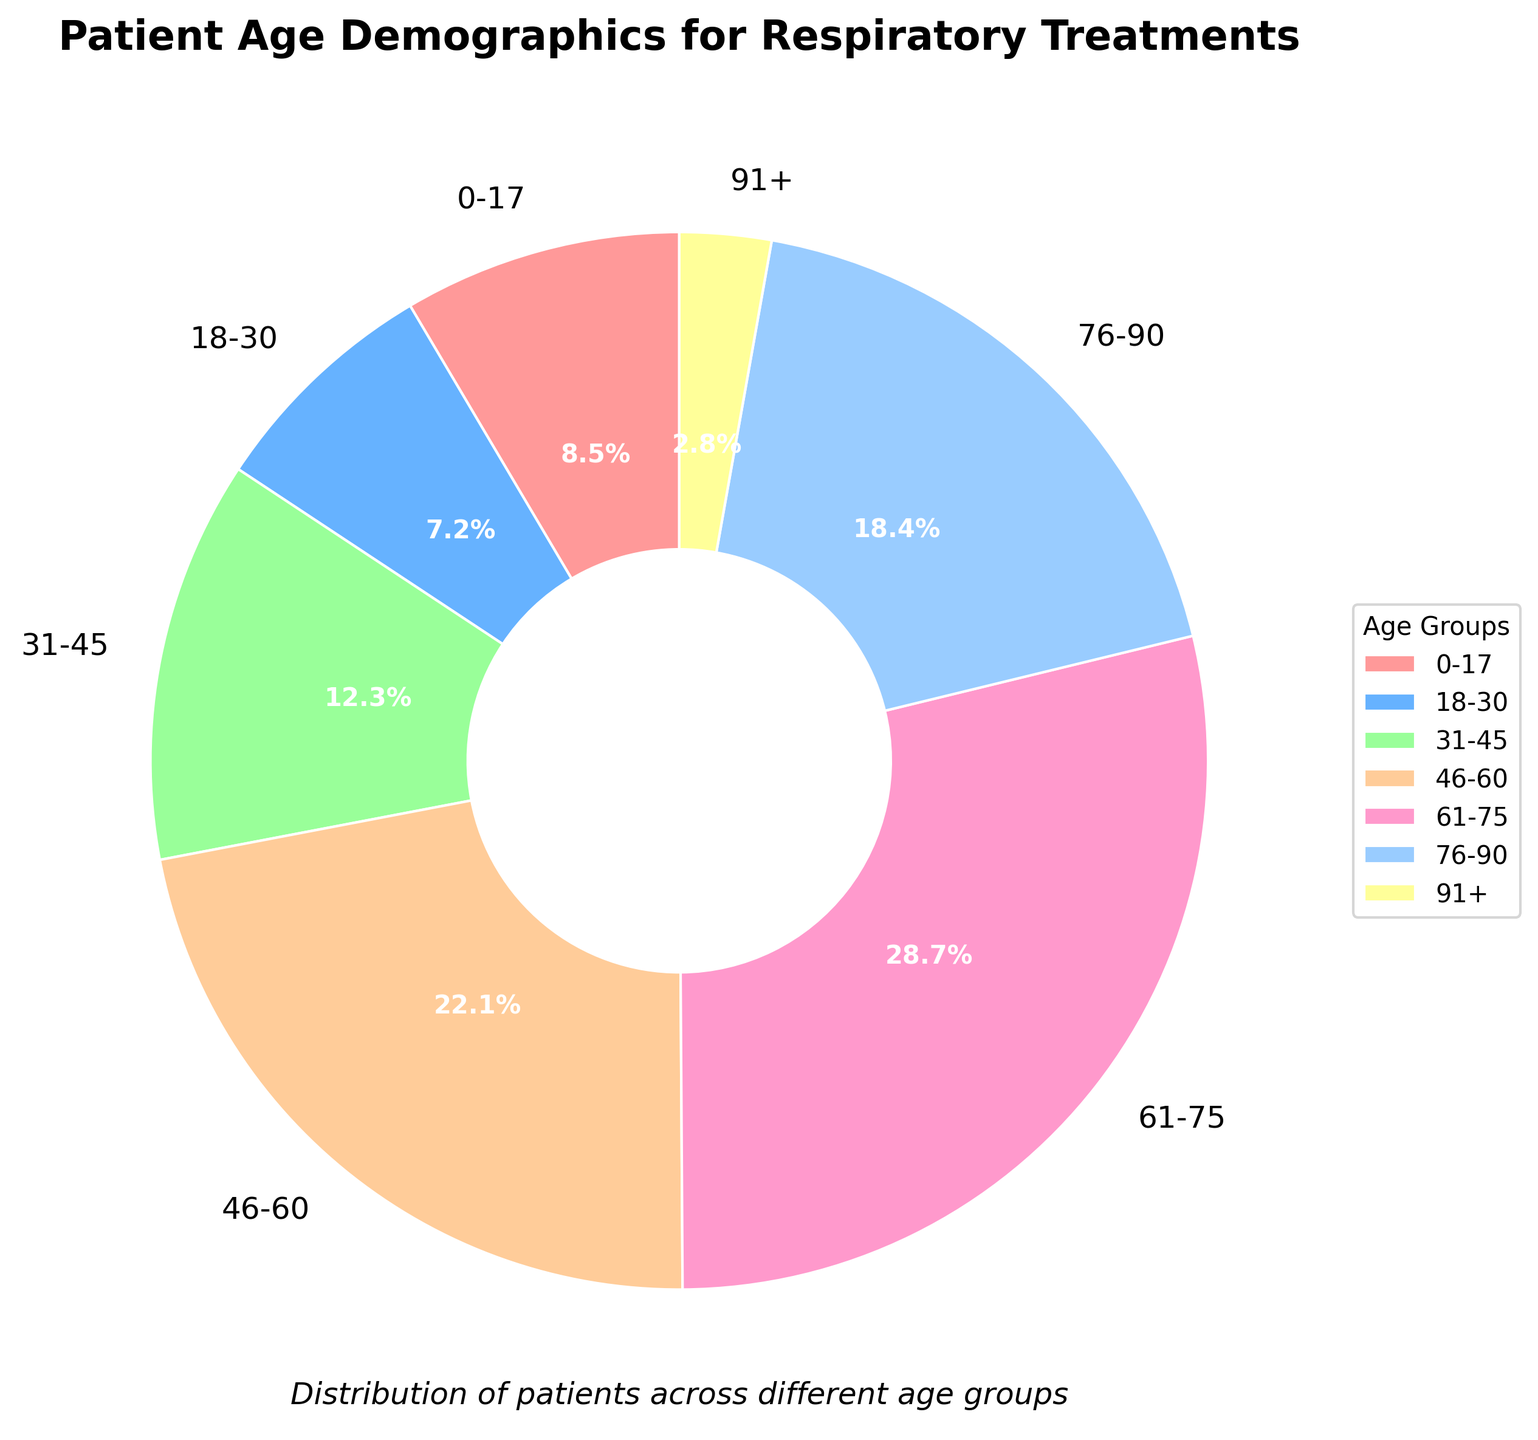Which age group has the highest percentage of patients for respiratory treatments? The age group 61-75 has the highest percentage of patients. This can be seen from the pie chart, where the 61-75 segment is the largest and is annotated with 28.7%.
Answer: 61-75 Which two age groups have the smallest combined percentage of patients? The 0-17 and 91+ age groups have the smallest combined percentage. The percentages are 8.5% and 2.8%, so their combined total is 8.5 + 2.8 = 11.3%.
Answer: 0-17 and 91+ What is the total percentage of patients aged 46 and older? To find the total percentage of patients aged 46 and older, sum the percentages of the 46-60, 61-75, 76-90, and 91+ groups: 22.1 + 28.7 + 18.4 + 2.8 = 72%.
Answer: 72% Are patients aged 31-45 more or less than those aged 76-90 in terms of percentage? Patients aged 31-45 make up 12.3% of the total, whereas those aged 76-90 make up 18.4%. Since 12.3% is less than 18.4%, there are fewer patients aged 31-45 than those aged 76-90.
Answer: Less Which age group is represented by the red-colored segment in the pie chart? The red-colored segment corresponds to the 0-17 age group. This can be identified by matching the color in the legend to the corresponding segment in the chart.
Answer: 0-17 What is the difference in percentage between the 61-75 age group and the 18-30 age group? The percentage for the 61-75 age group is 28.7%, and for the 18-30 age group, it is 7.2%. The difference is 28.7 - 7.2 = 21.5%.
Answer: 21.5% What are the combined percentages of patients aged 18 to 60? To find the combined percentage of patients in the 18-30, 31-45, and 46-60 age groups, add their percentages: 7.2 + 12.3 + 22.1 = 41.6%.
Answer: 41.6% Compare the percentages of patients aged 0-17 to those aged 18-30. The 0-17 age group consists of 8.5% of patients while the 18-30 age group consists of 7.2%. Since 8.5% is greater than 7.2%, the 0-17 age group has a higher percentage of patients.
Answer: 0-17 is higher Which age group is represented by the smallest segment in the pie chart? The smallest segment in the pie chart corresponds to the 91+ age group, which has a percentage of 2.8%.
Answer: 91+ What is the sum of the percentages of the three largest age groups? The three largest age groups are 61-75 (28.7%), 46-60 (22.1%), and 76-90 (18.4%). Summing these, 28.7 + 22.1 + 18.4 = 69.2%.
Answer: 69.2% 